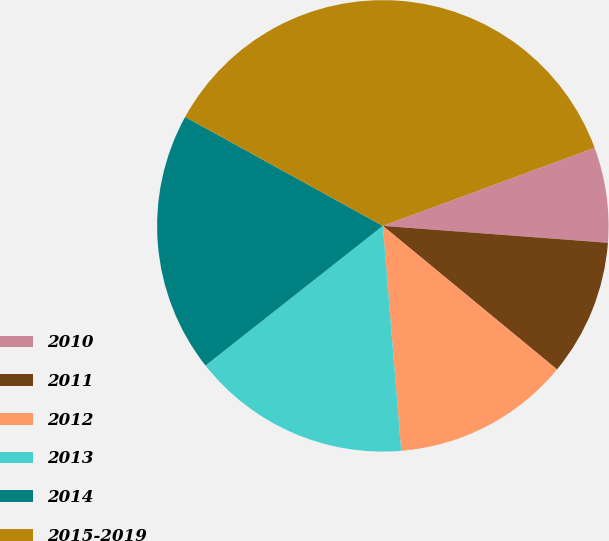Convert chart to OTSL. <chart><loc_0><loc_0><loc_500><loc_500><pie_chart><fcel>2010<fcel>2011<fcel>2012<fcel>2013<fcel>2014<fcel>2015-2019<nl><fcel>6.82%<fcel>9.78%<fcel>12.73%<fcel>15.68%<fcel>18.64%<fcel>36.36%<nl></chart> 